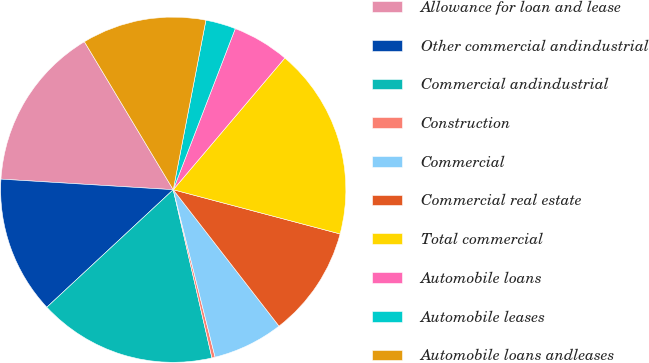Convert chart. <chart><loc_0><loc_0><loc_500><loc_500><pie_chart><fcel>Allowance for loan and lease<fcel>Other commercial andindustrial<fcel>Commercial andindustrial<fcel>Construction<fcel>Commercial<fcel>Commercial real estate<fcel>Total commercial<fcel>Automobile loans<fcel>Automobile leases<fcel>Automobile loans andleases<nl><fcel>15.42%<fcel>12.9%<fcel>16.68%<fcel>0.3%<fcel>6.6%<fcel>10.38%<fcel>17.94%<fcel>5.34%<fcel>2.82%<fcel>11.64%<nl></chart> 